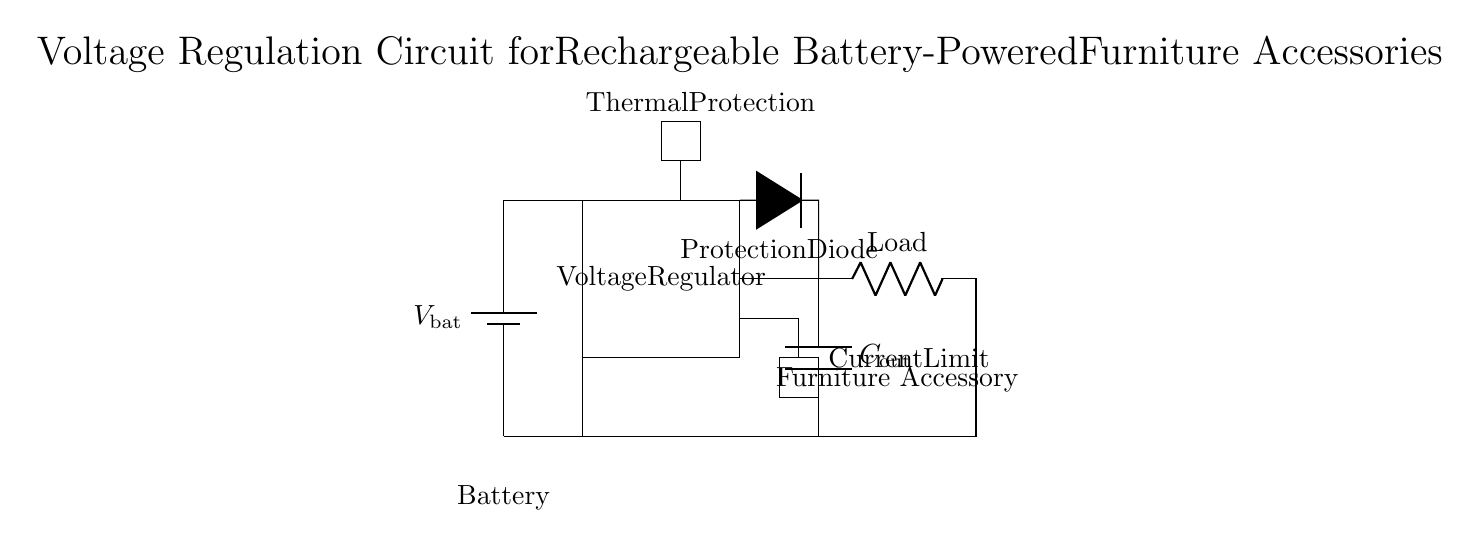What is the main function of the voltage regulator? The voltage regulator stabilizes the output voltage to a constant level, even when the input voltage or load changes.
Answer: Stabilization What component provides thermal protection in this circuit? The thermal protection is indicated by a rectangle labeled 'Thermal Protection,' which monitors temperature to prevent overheating.
Answer: Thermal Protection What type of load is connected in this circuit? The load in the circuit is shown as a resistor labeled 'Load,' which represents the furniture accessory being powered.
Answer: Resistor How many protections are present in this circuit? There are two protections indicated: the protection diode and the thermal protection. This can be counted in the diagram.
Answer: Two What does the current limit section do? The current limit section is a component that restricts the current flowing through the circuit to prevent damage from excessive current.
Answer: Restricts Current What does the protection diode do in this circuit? The protection diode allows current to flow in one direction only, helping to prevent reverse current that could damage the circuit components.
Answer: Prevents Reverse Current 